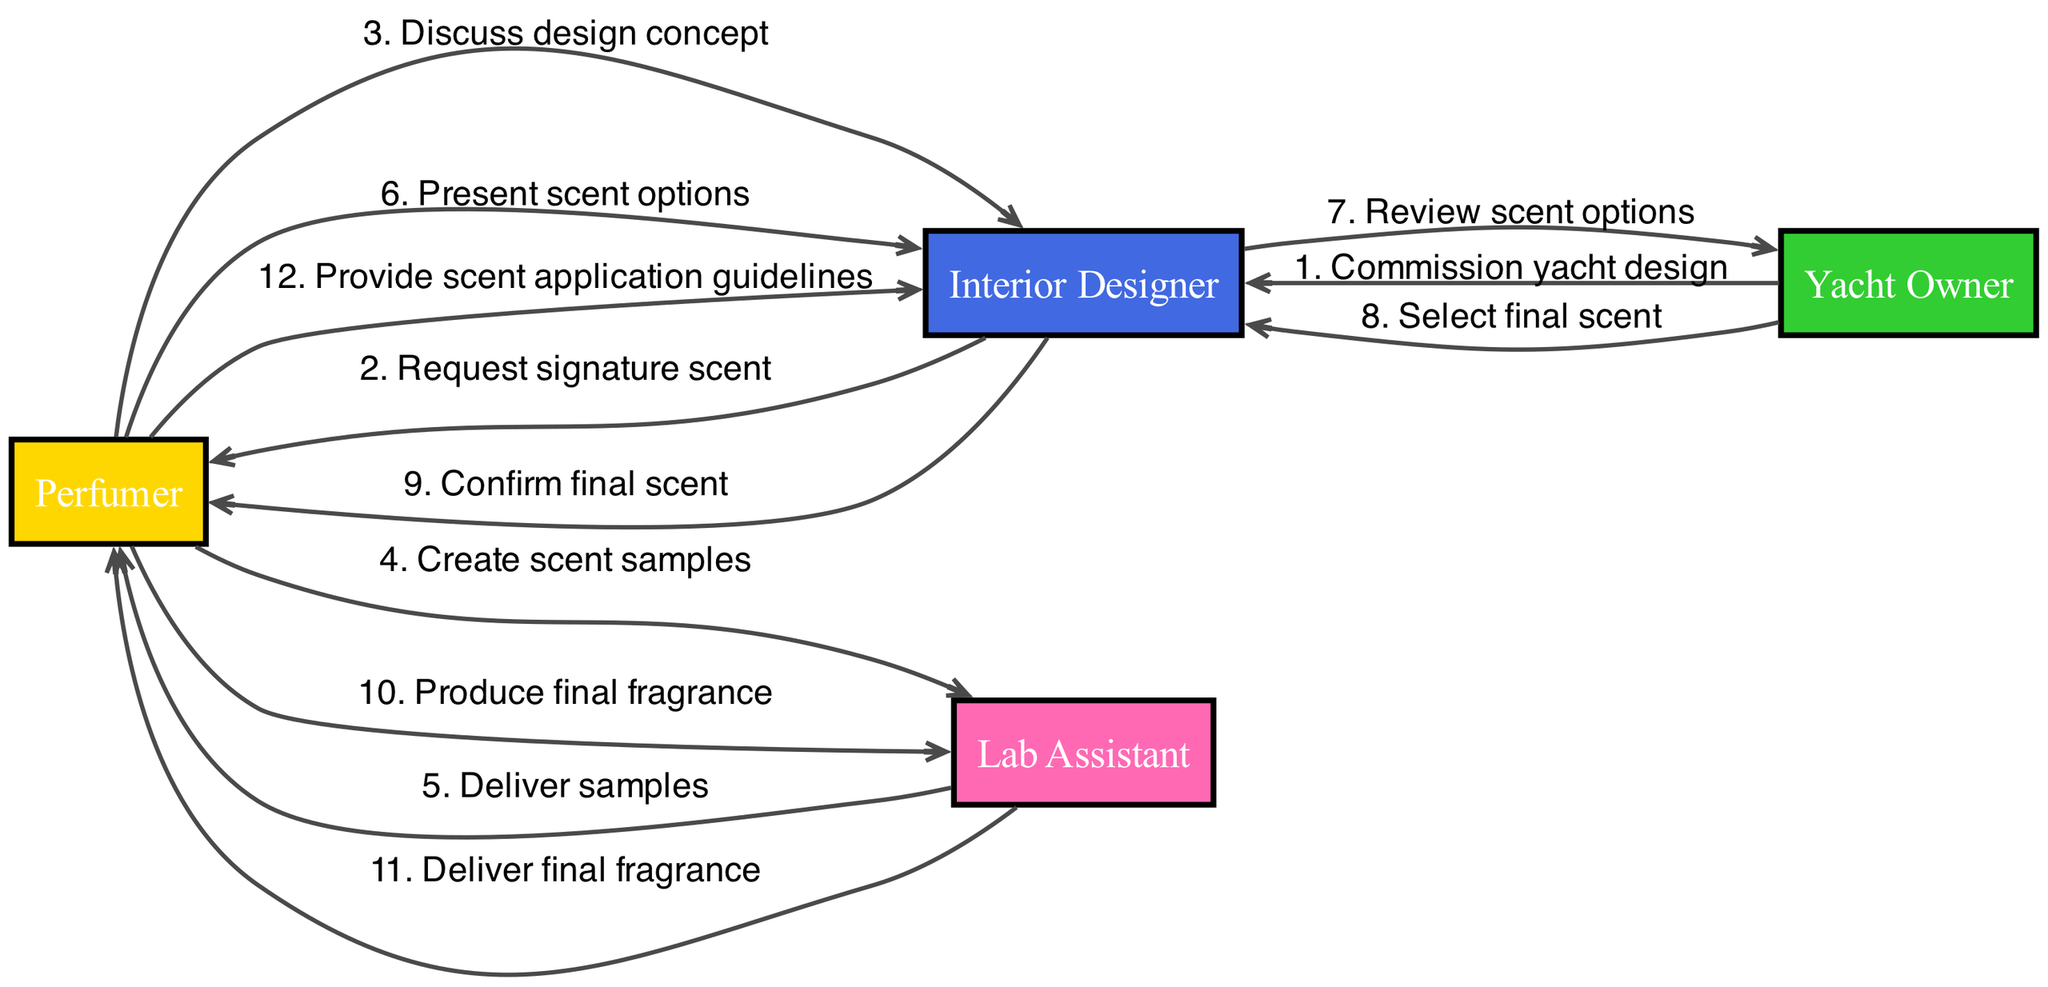What is the first action taken in the sequence? The first action is initiated by the Yacht Owner who commissions the yacht design. It is indicated as the initial step in the sequence of interactions.
Answer: Commission yacht design How many actors are involved in the process? The diagram includes four distinct actors: the Perfumer, Interior Designer, Yacht Owner, and Lab Assistant. This can be counted from the list of actors presented.
Answer: Four Who requests the signature scent? The Interior Designer is responsible for requesting the signature scent from the Perfumer as seen in the sequence flow.
Answer: Request signature scent What happens after the scent samples are created? After the Perfumer creates the scent samples, they are delivered to the Perfumer by the Lab Assistant. This represents the next action in the sequence following the creation of the samples.
Answer: Deliver samples Which actor confirms the final scent? The actor who confirms the final scent is the Interior Designer, as indicated in the sequence where they communicate this to the Perfumer.
Answer: Confirm final scent How many actions involve the Lab Assistant? The Lab Assistant is involved in two actions: delivering samples and delivering the final fragrance. By reviewing the sequence, these actions can be identified.
Answer: Two What is the last action in the sequence? The final action is the Perfumer providing scent application guidelines to the Interior Designer, marking the completion of the collaboration process.
Answer: Provide scent application guidelines What is the role of the Yacht Owner in this process? The Yacht Owner commissions the yacht design and selects the final scent, contributing significantly to the overall process as indicated in the sequence.
Answer: Commission yacht design and select final scent What directly follows the presentation of scent options? The action directly following the presentation of scent options is the review of these options by the Interior Designer with the Yacht Owner. This connects two significant parts of the interaction.
Answer: Review scent options 